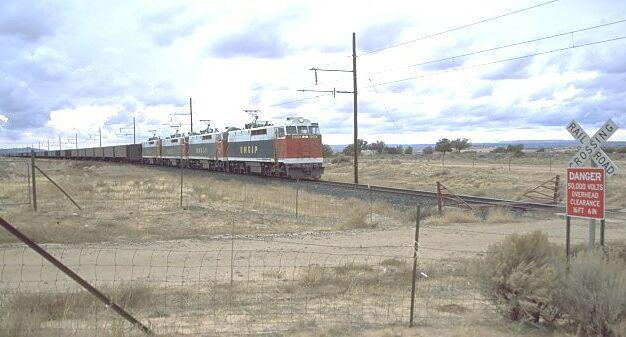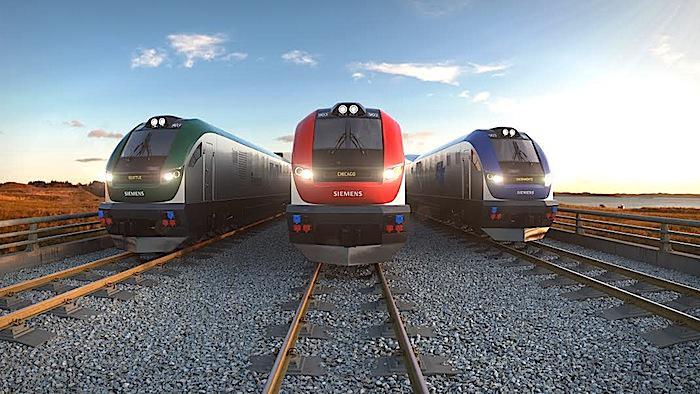The first image is the image on the left, the second image is the image on the right. Evaluate the accuracy of this statement regarding the images: "The train in the image to the right features a fair amount of green paint.". Is it true? Answer yes or no. No. The first image is the image on the left, the second image is the image on the right. For the images displayed, is the sentence "At least one train has a visibly sloped front with a band of solid color around the windshield." factually correct? Answer yes or no. Yes. 